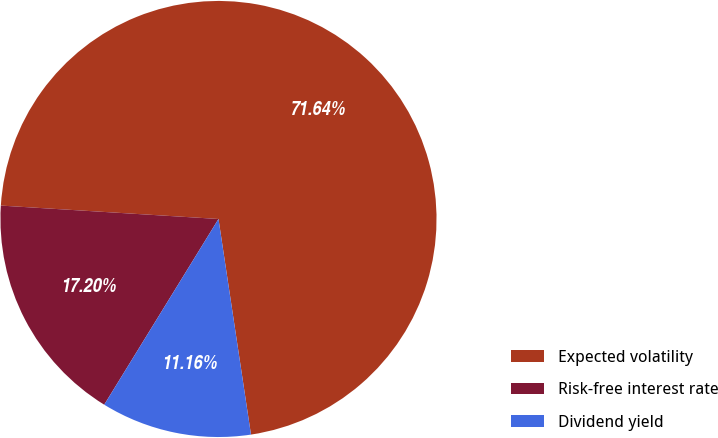Convert chart to OTSL. <chart><loc_0><loc_0><loc_500><loc_500><pie_chart><fcel>Expected volatility<fcel>Risk-free interest rate<fcel>Dividend yield<nl><fcel>71.64%<fcel>17.2%<fcel>11.16%<nl></chart> 